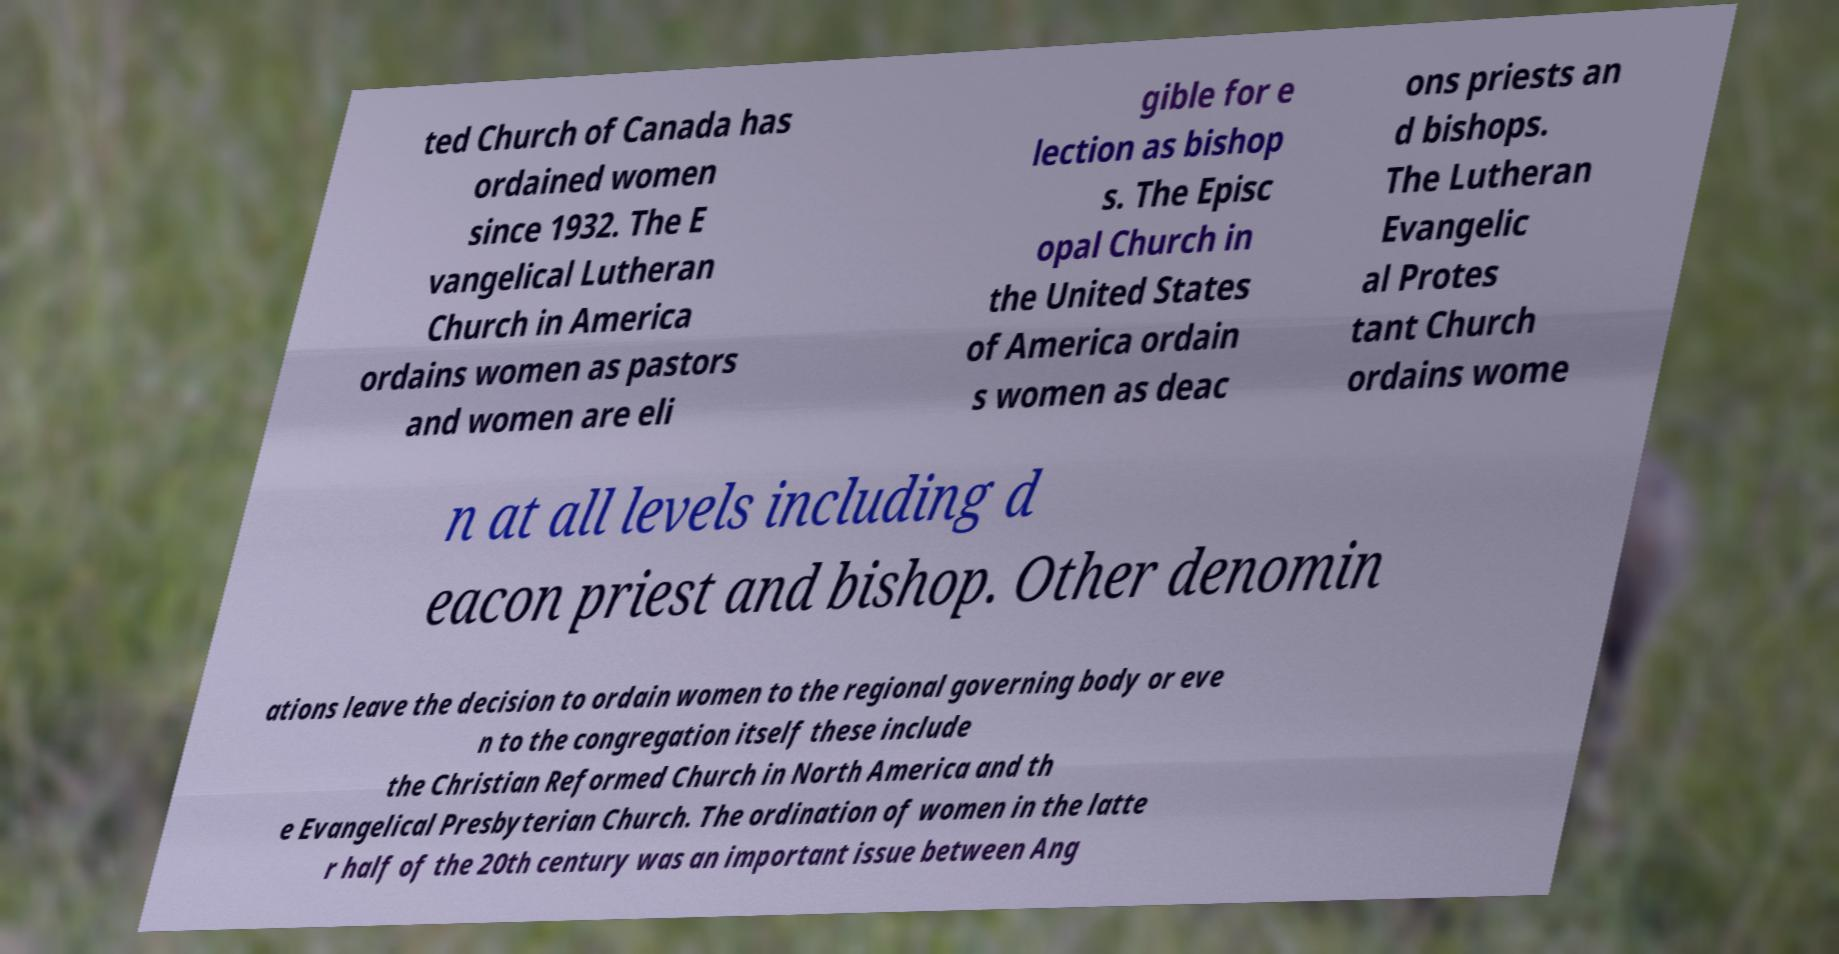There's text embedded in this image that I need extracted. Can you transcribe it verbatim? ted Church of Canada has ordained women since 1932. The E vangelical Lutheran Church in America ordains women as pastors and women are eli gible for e lection as bishop s. The Episc opal Church in the United States of America ordain s women as deac ons priests an d bishops. The Lutheran Evangelic al Protes tant Church ordains wome n at all levels including d eacon priest and bishop. Other denomin ations leave the decision to ordain women to the regional governing body or eve n to the congregation itself these include the Christian Reformed Church in North America and th e Evangelical Presbyterian Church. The ordination of women in the latte r half of the 20th century was an important issue between Ang 